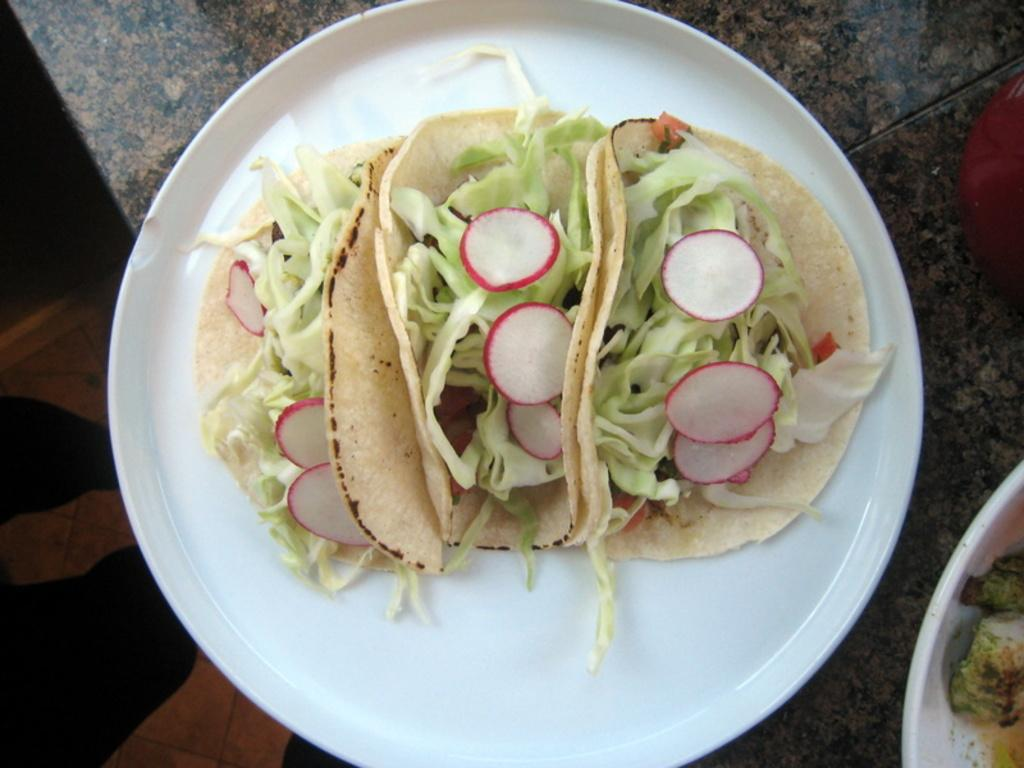What is on the surface in the image? There is a white plate on the surface in the image. What is on the plate? There is a food item on the plate. What type of vegetable is present on the food item? There are pieces of cabbage on the food item. Are there any other ingredients visible on the food item? Yes, there are other unspecified items on the food item. What type of thread is used to hold the bread together in the image? There is no bread present in the image, and therefore no thread is used to hold it together. 